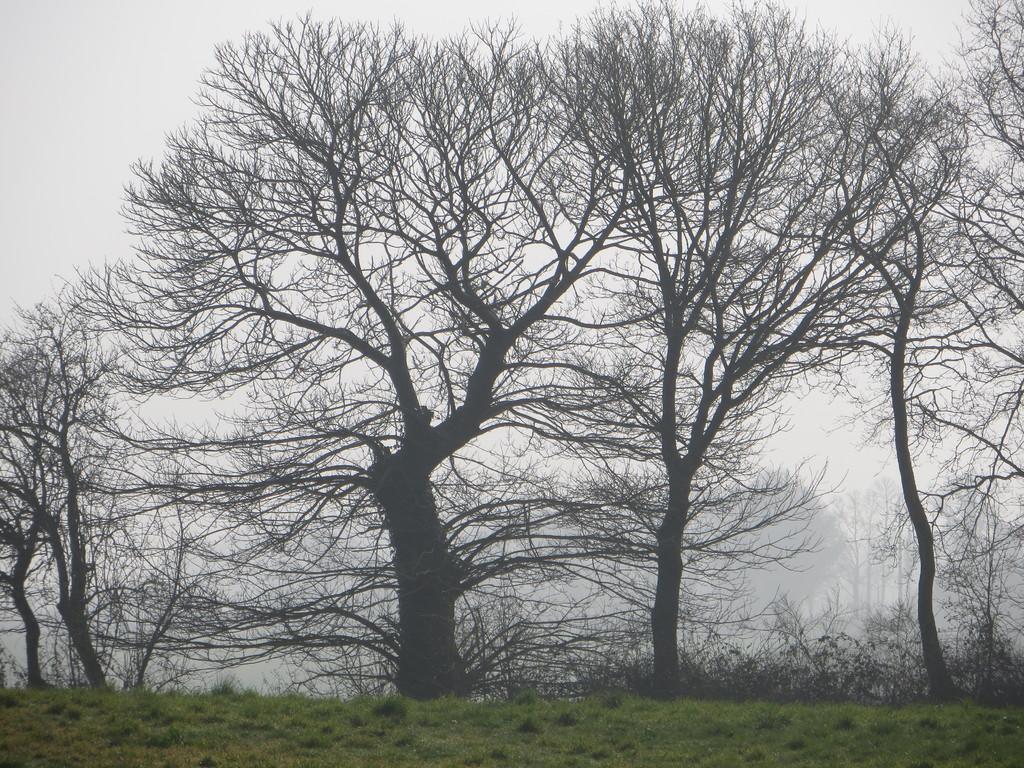How would you summarize this image in a sentence or two? In this image, I can see the trees with branches. At the bottom of the image, I think this is the grass. In the background, I can see few more trees, which are covered with the fog. 